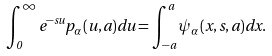Convert formula to latex. <formula><loc_0><loc_0><loc_500><loc_500>\int _ { 0 } ^ { \infty } e ^ { - s u } p _ { \alpha } ( u , a ) d u = \int _ { - a } ^ { a } \psi _ { \alpha } ( x , s , a ) d x .</formula> 